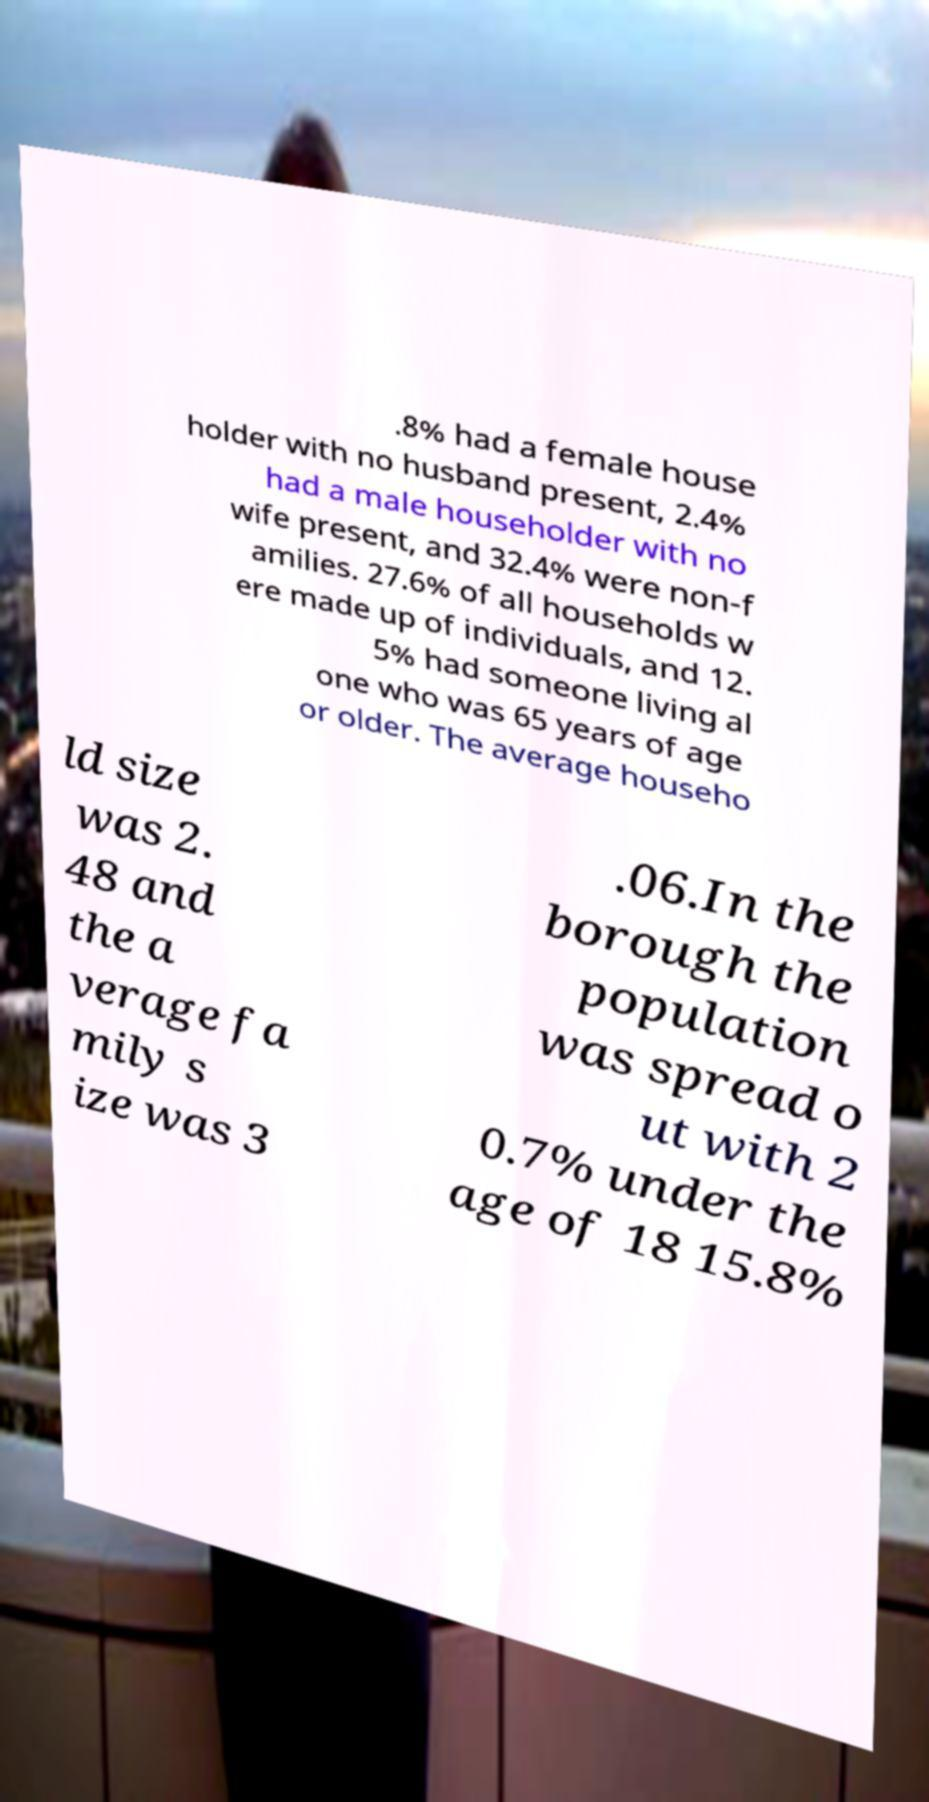Can you read and provide the text displayed in the image?This photo seems to have some interesting text. Can you extract and type it out for me? .8% had a female house holder with no husband present, 2.4% had a male householder with no wife present, and 32.4% were non-f amilies. 27.6% of all households w ere made up of individuals, and 12. 5% had someone living al one who was 65 years of age or older. The average househo ld size was 2. 48 and the a verage fa mily s ize was 3 .06.In the borough the population was spread o ut with 2 0.7% under the age of 18 15.8% 